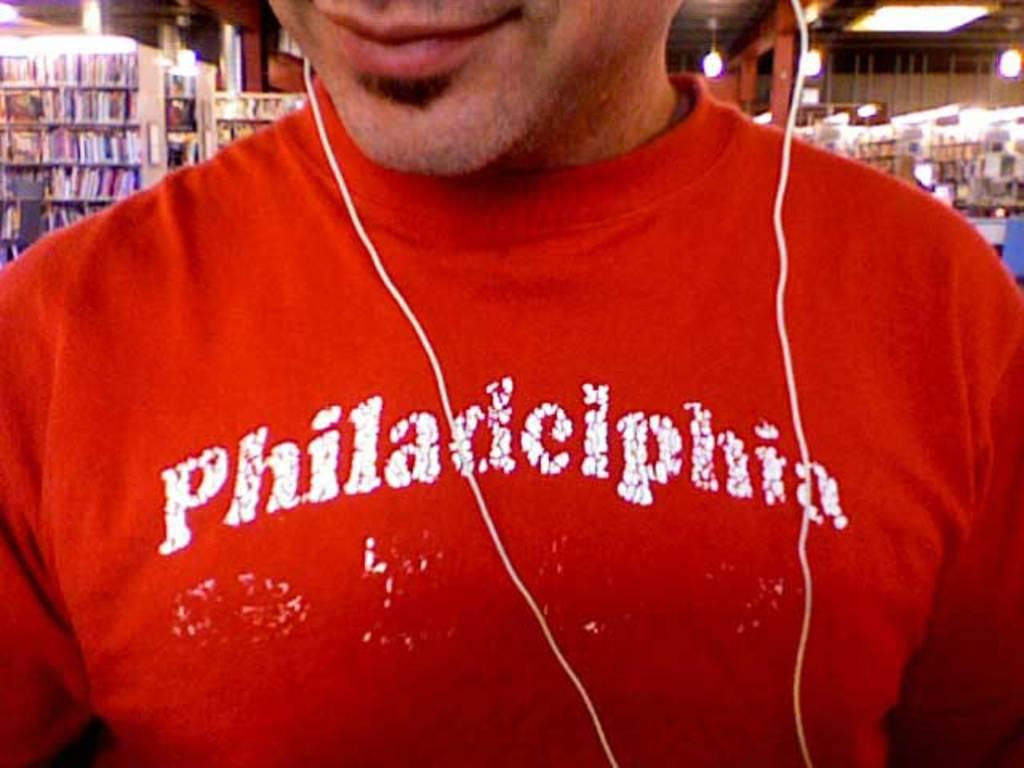Who is present in the image? There is a man in the image. What is the man wearing? The man is wearing a red T-shirt. What can be seen connected to the man's ears? There are two white earphone wires in the image. What is visible in the background of the image? There is a store in the background of the image. What type of toothbrush is the man using in the image? There is no toothbrush present in the image. What kind of corn is being sold in the store in the background? The image does not show any corn or store products, as it focuses on the man and his earphone wires. 